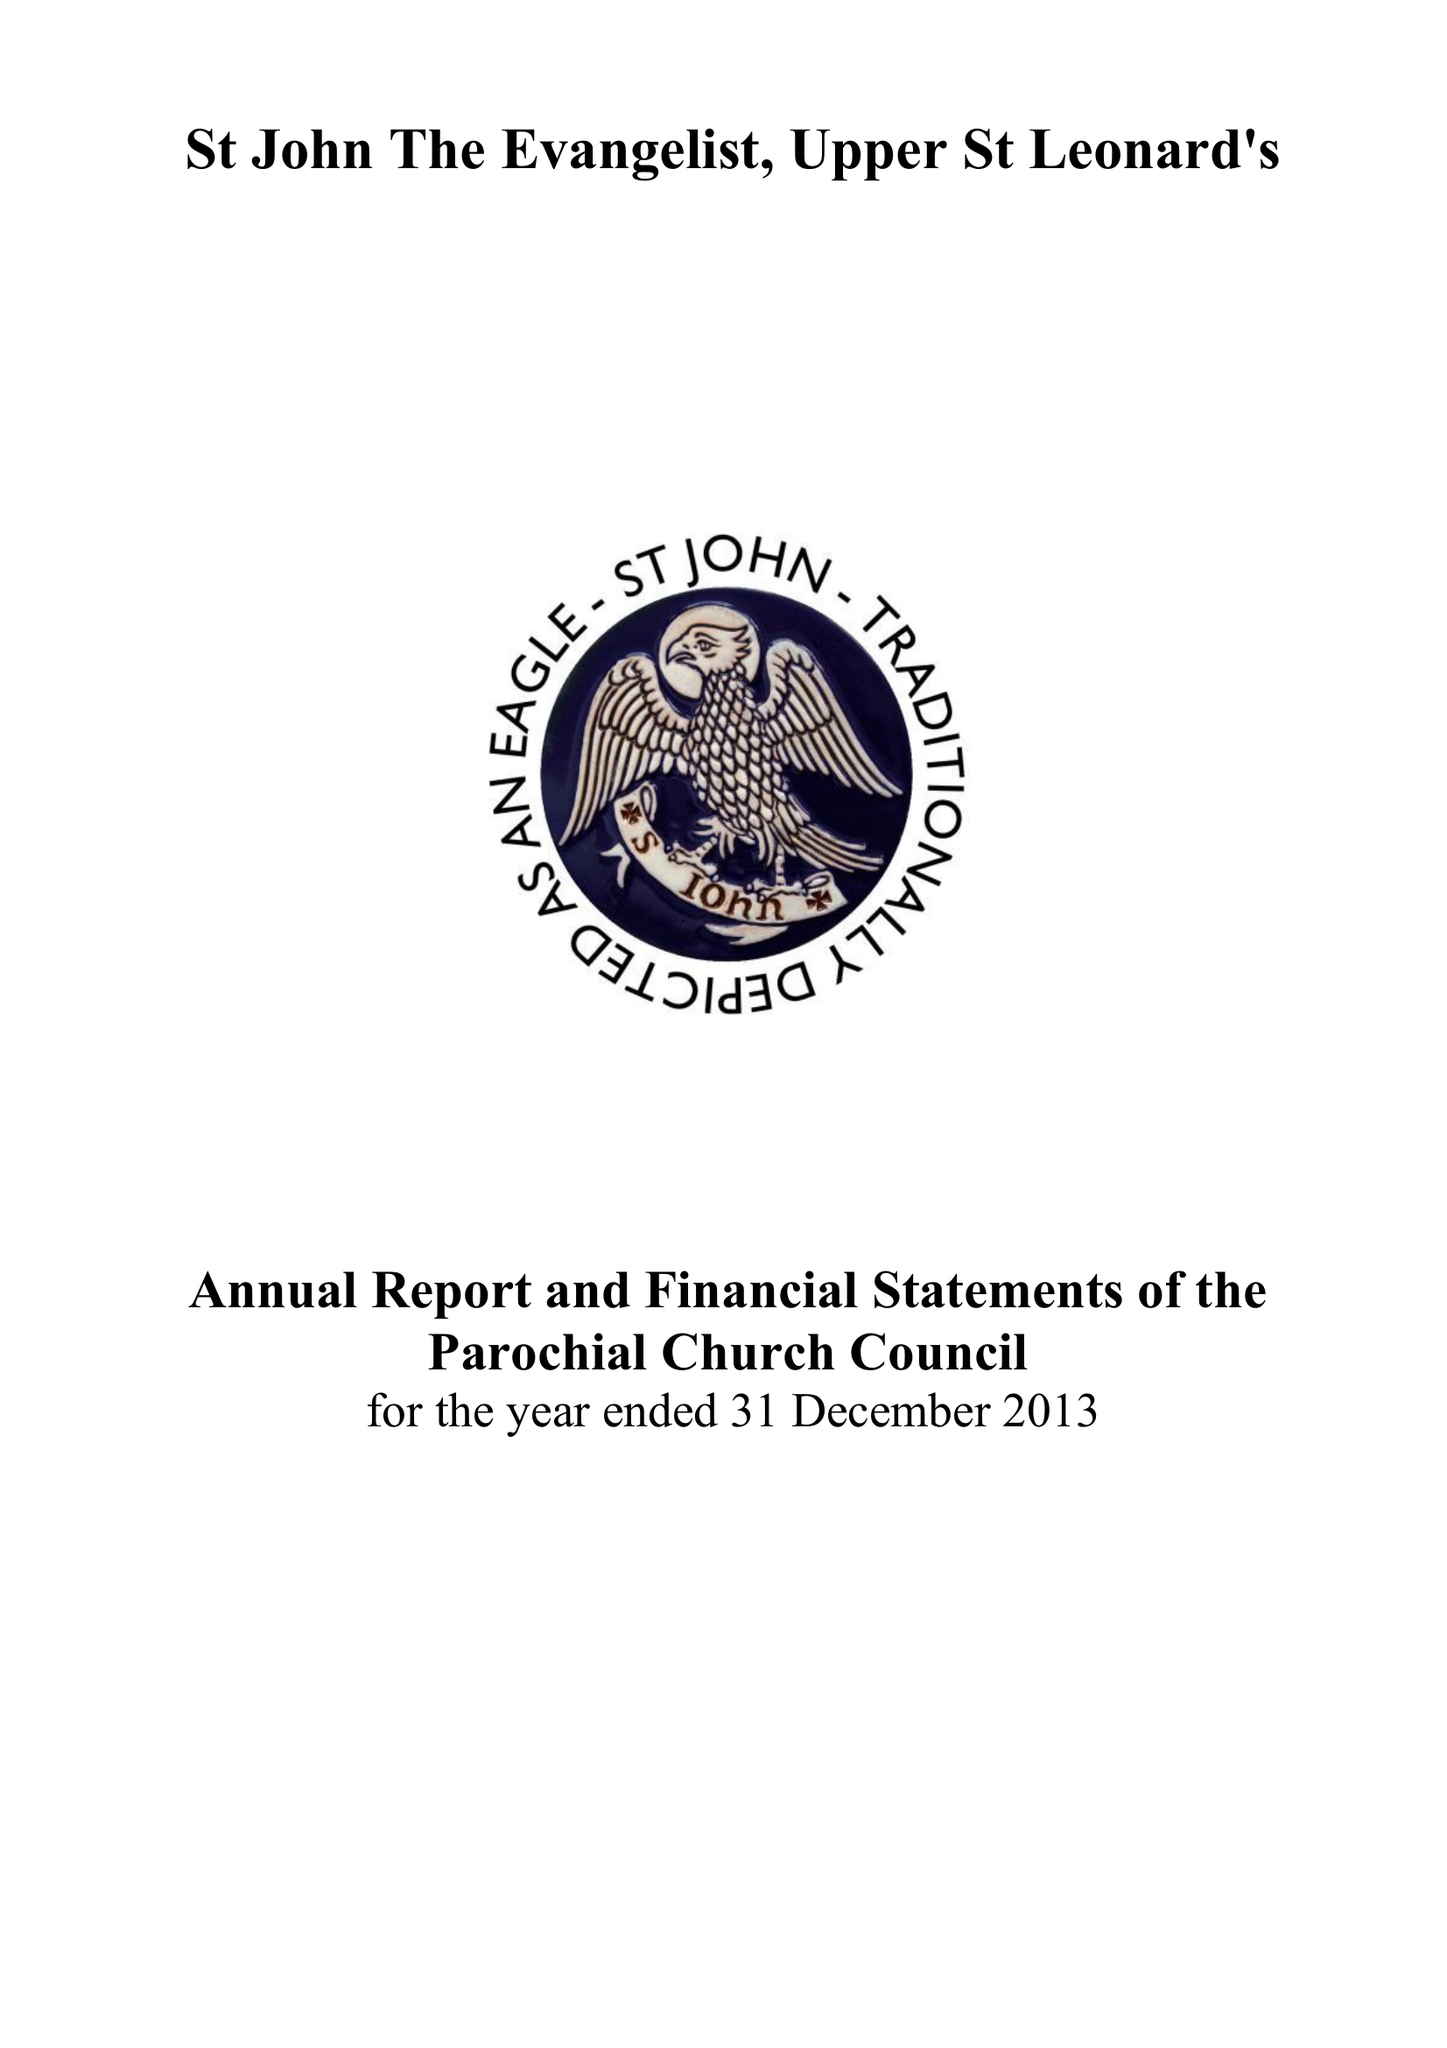What is the value for the address__postcode?
Answer the question using a single word or phrase. TN38 0LF 